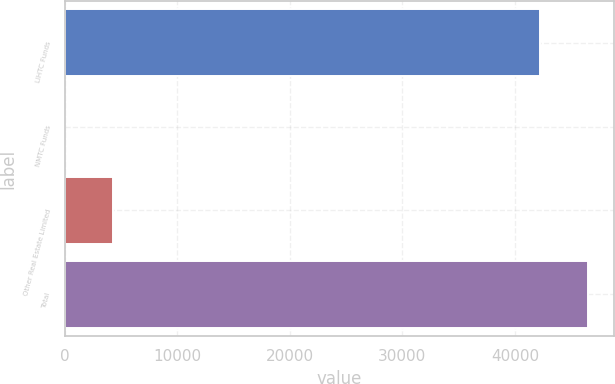Convert chart. <chart><loc_0><loc_0><loc_500><loc_500><bar_chart><fcel>LIHTC Funds<fcel>NMTC Funds<fcel>Other Real Estate Limited<fcel>Total<nl><fcel>42244<fcel>12<fcel>4252.7<fcel>46484.7<nl></chart> 